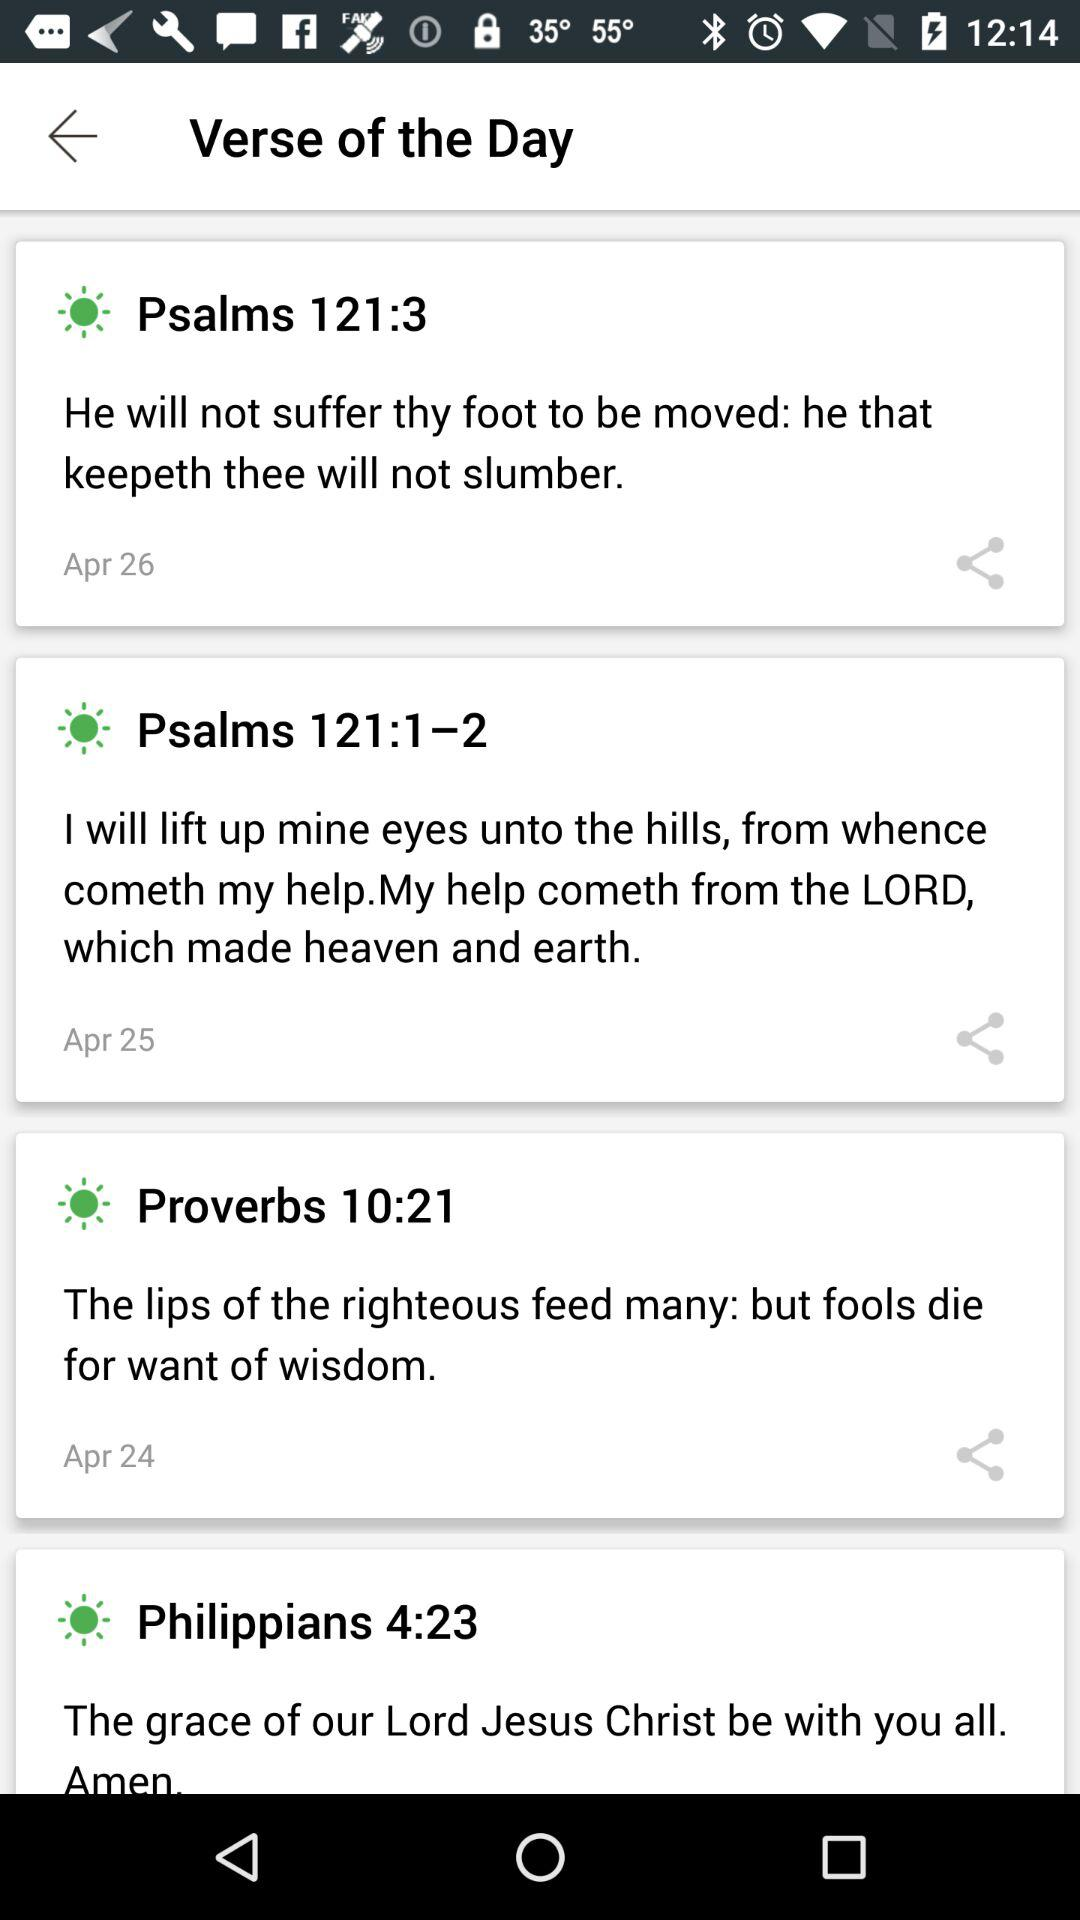Which "Bible" verse is for April 25? The "Bible" verse for April 25 is "Psalms 121:1–2". 